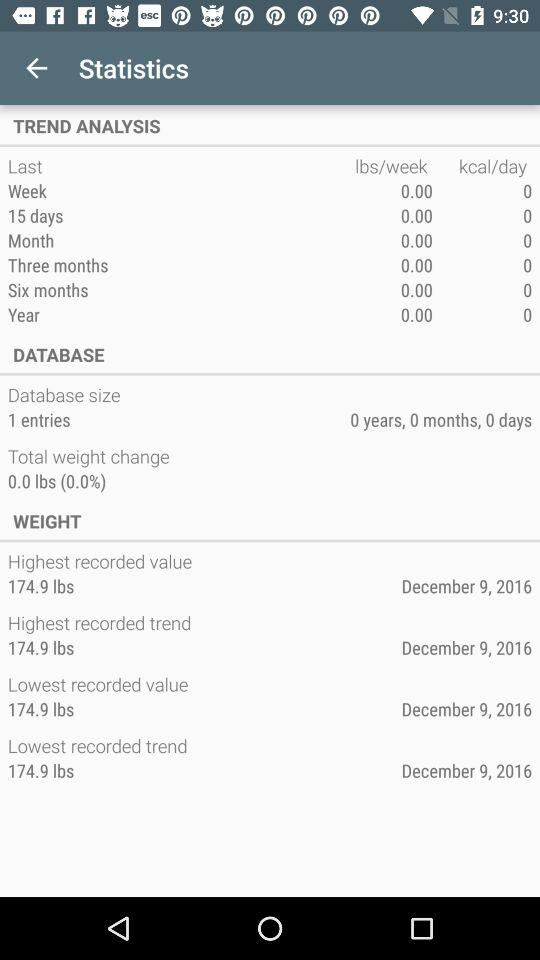What is the number of entries in the database size? The number of entries is 1. 